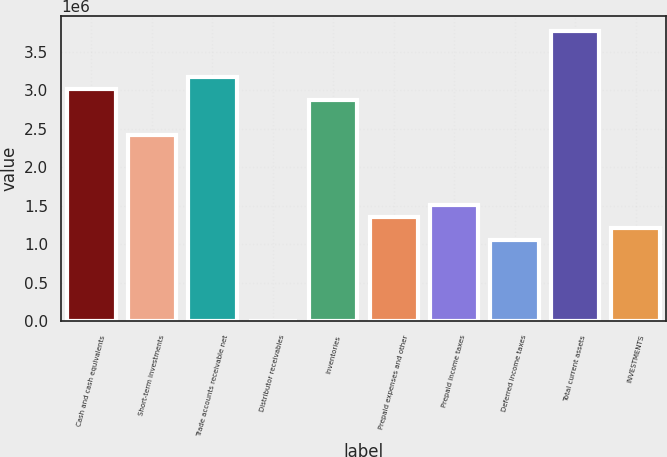<chart> <loc_0><loc_0><loc_500><loc_500><bar_chart><fcel>Cash and cash equivalents<fcel>Short-term investments<fcel>Trade accounts receivable net<fcel>Distributor receivables<fcel>Inventories<fcel>Prepaid expenses and other<fcel>Prepaid income taxes<fcel>Deferred income taxes<fcel>Total current assets<fcel>INVESTMENTS<nl><fcel>3.01666e+06<fcel>2.41346e+06<fcel>3.16746e+06<fcel>666<fcel>2.86586e+06<fcel>1.35786e+06<fcel>1.50866e+06<fcel>1.05626e+06<fcel>3.77066e+06<fcel>1.20706e+06<nl></chart> 